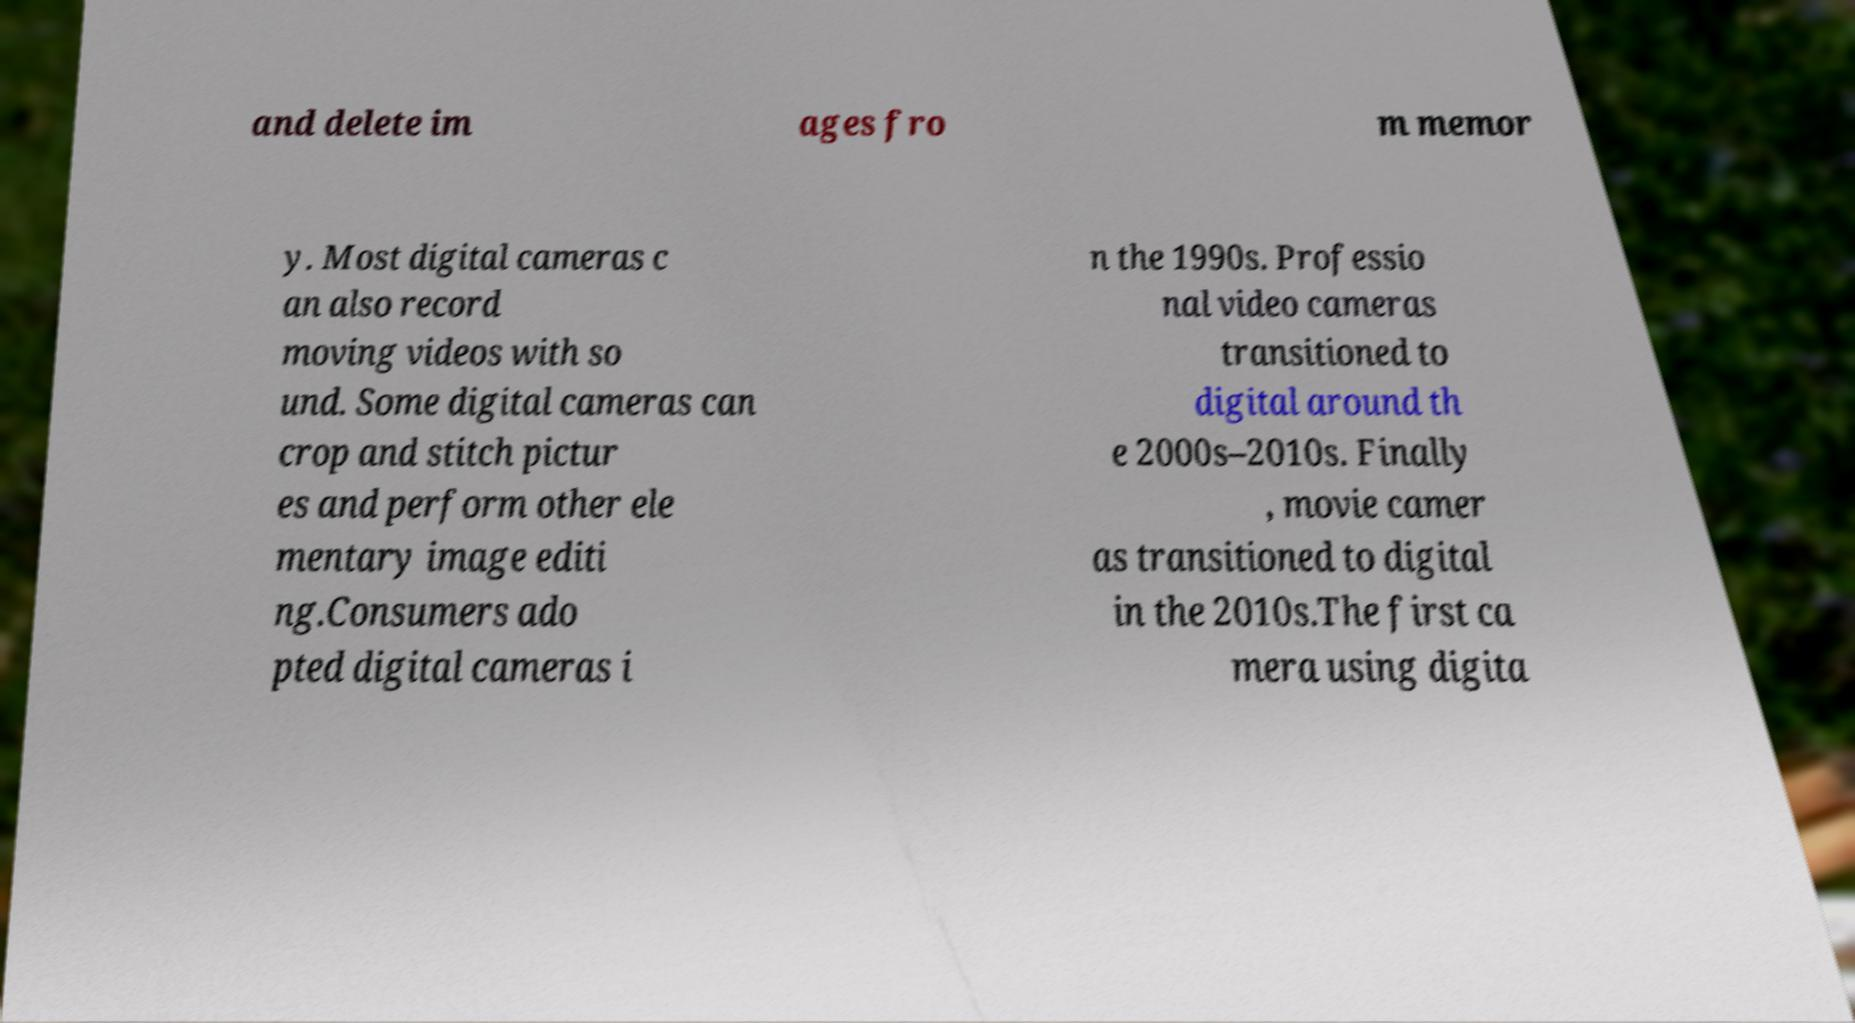What messages or text are displayed in this image? I need them in a readable, typed format. and delete im ages fro m memor y. Most digital cameras c an also record moving videos with so und. Some digital cameras can crop and stitch pictur es and perform other ele mentary image editi ng.Consumers ado pted digital cameras i n the 1990s. Professio nal video cameras transitioned to digital around th e 2000s–2010s. Finally , movie camer as transitioned to digital in the 2010s.The first ca mera using digita 